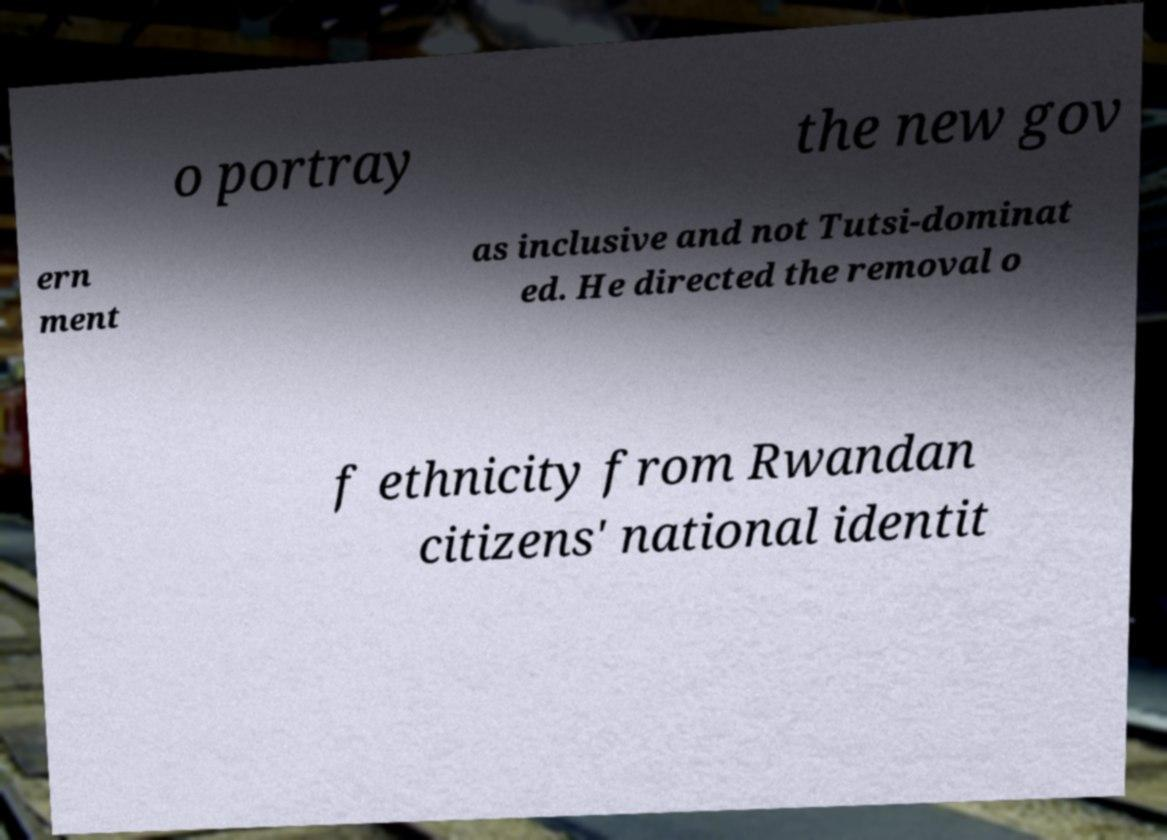Please read and relay the text visible in this image. What does it say? o portray the new gov ern ment as inclusive and not Tutsi-dominat ed. He directed the removal o f ethnicity from Rwandan citizens' national identit 